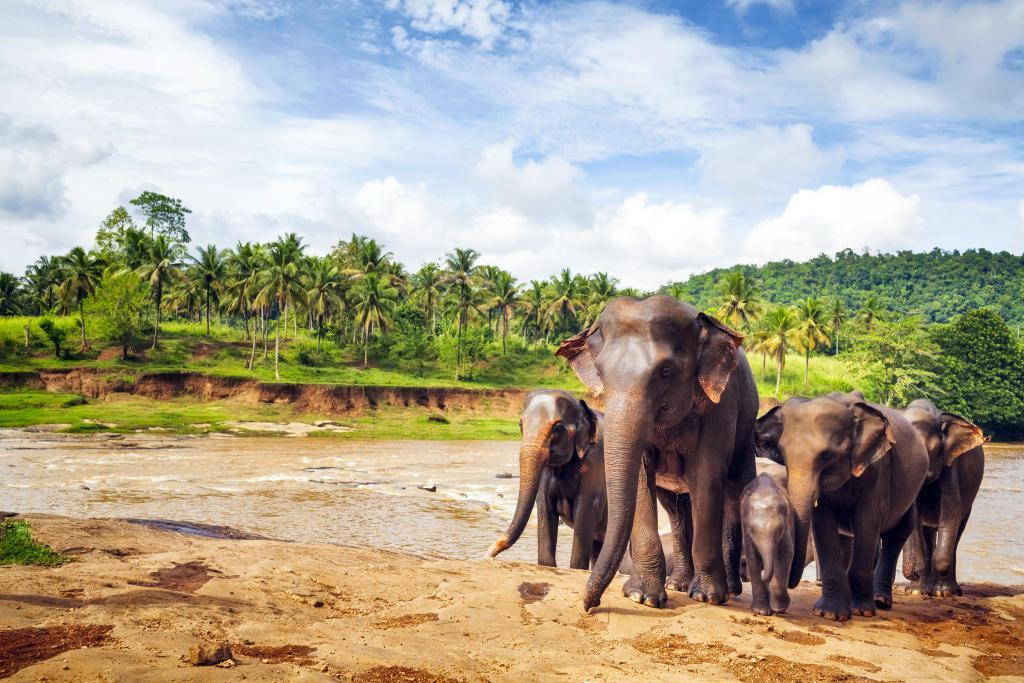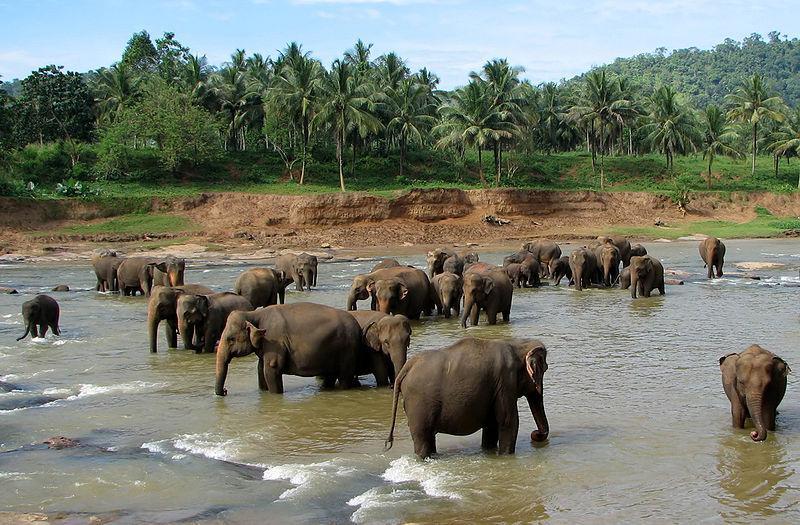The first image is the image on the left, the second image is the image on the right. Given the left and right images, does the statement "An image shows at least ten elephants completely surrounded by water." hold true? Answer yes or no. Yes. The first image is the image on the left, the second image is the image on the right. Given the left and right images, does the statement "Several elephants are in the water." hold true? Answer yes or no. Yes. 